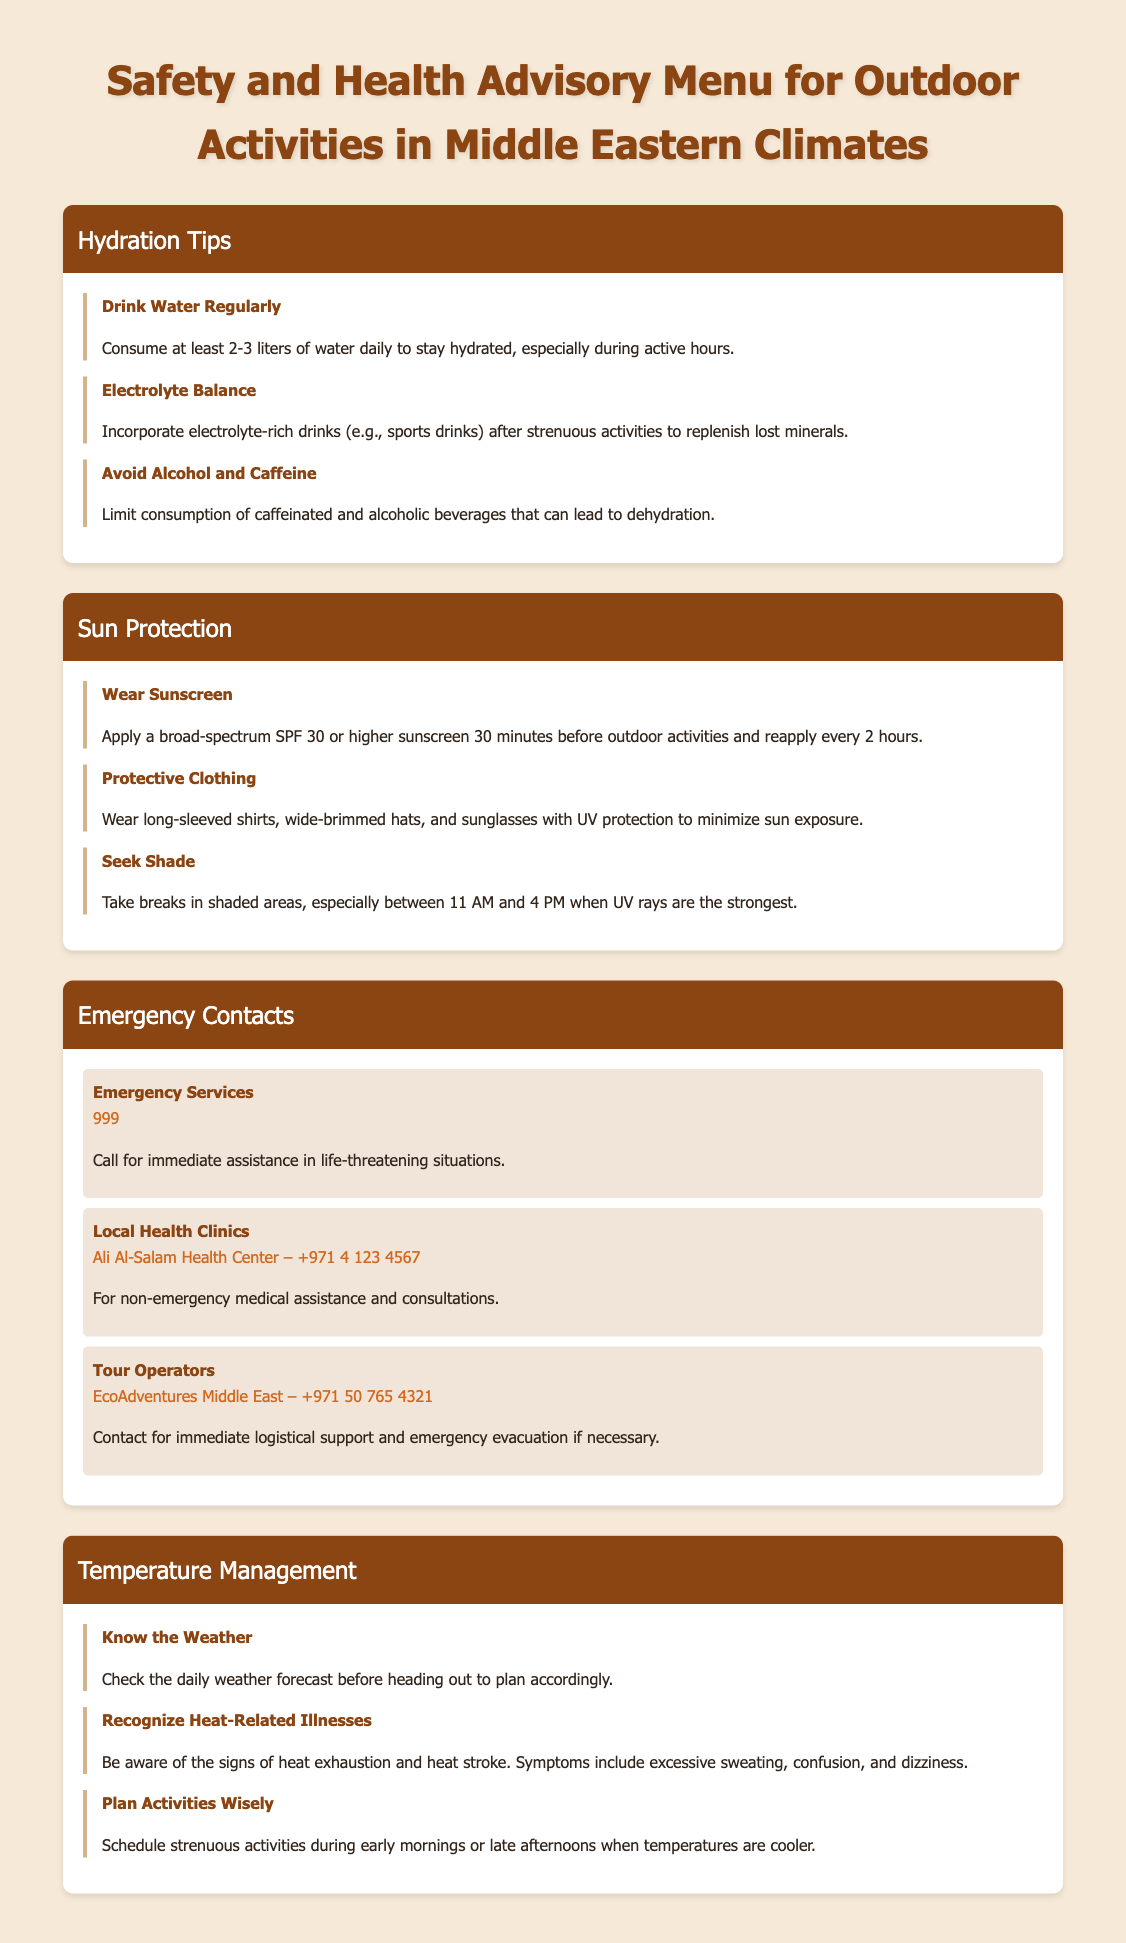what is the recommended daily water intake? The document advises consuming at least 2-3 liters of water daily for hydration.
Answer: 2-3 liters what SPF should sunscreen be? The document states to apply a broad-spectrum SPF 30 or higher sunscreen for sun protection.
Answer: SPF 30 what number do you call for emergency services? The document lists 999 as the contact number for immediate assistance in life-threatening situations.
Answer: 999 what time of day should you seek shade? According to the document, breaks in shaded areas should be taken especially between 11 AM and 4 PM when UV rays are strongest.
Answer: 11 AM to 4 PM what is the name of the local health clinic mentioned? The document mentions Ali Al-Salam Health Center as a local health clinic for non-emergency assistance.
Answer: Ali Al-Salam Health Center what should you do after strenuous activities? The document advises incorporating electrolyte-rich drinks after strenuous activities to replenish lost minerals.
Answer: Drink electrolyte-rich drinks what are the signs of heat exhaustion? The document indicates that excessive sweating, confusion, and dizziness are symptoms of heat exhaustion.
Answer: Excessive sweating, confusion, dizziness when is it best to schedule strenuous activities? The document suggests scheduling strenuous activities during early mornings or late afternoons.
Answer: Early mornings or late afternoons what is the contact number for EcoAdventures Middle East? The document provides the contact number +971 50 765 4321 for EcoAdventures Middle East.
Answer: +971 50 765 4321 